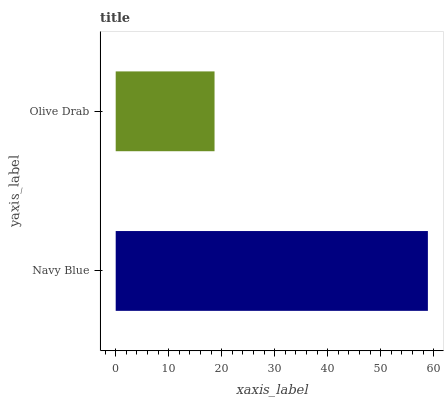Is Olive Drab the minimum?
Answer yes or no. Yes. Is Navy Blue the maximum?
Answer yes or no. Yes. Is Olive Drab the maximum?
Answer yes or no. No. Is Navy Blue greater than Olive Drab?
Answer yes or no. Yes. Is Olive Drab less than Navy Blue?
Answer yes or no. Yes. Is Olive Drab greater than Navy Blue?
Answer yes or no. No. Is Navy Blue less than Olive Drab?
Answer yes or no. No. Is Navy Blue the high median?
Answer yes or no. Yes. Is Olive Drab the low median?
Answer yes or no. Yes. Is Olive Drab the high median?
Answer yes or no. No. Is Navy Blue the low median?
Answer yes or no. No. 